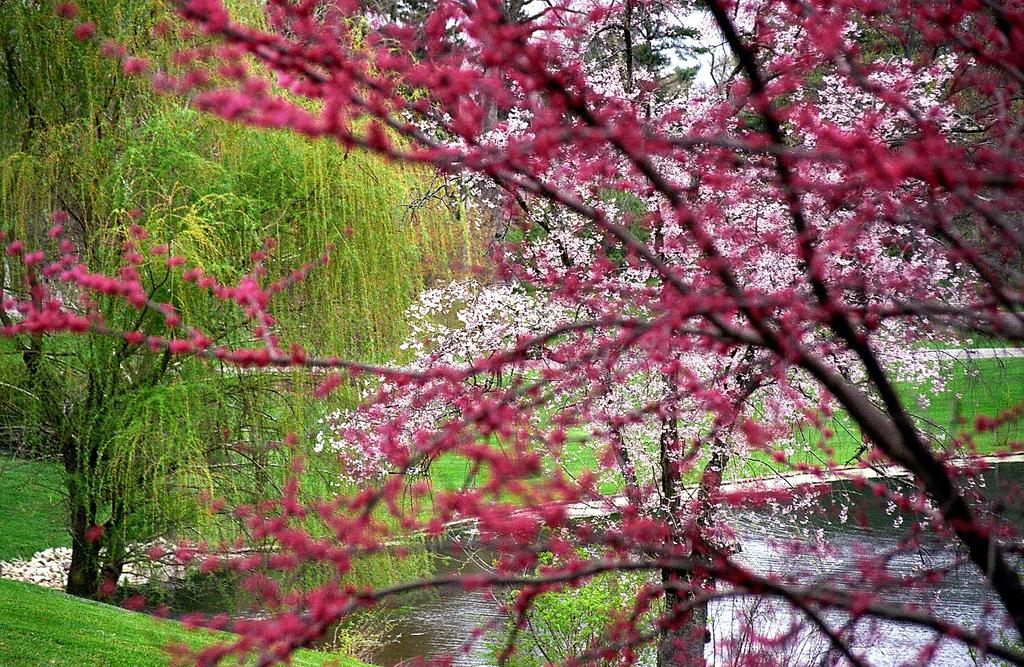What is visible in the image that represents a natural body of water? There is water visible in the image. What type of vegetation can be seen in the image? There are trees and flowers in the image. What type of ground cover is present in the image? There is grass on the ground in the image. Can you see a gun being used by someone in the image? There is no gun or person visible in the image. Is there a grandmother tending to the flowers in the image? There is no grandmother or person visible in the image. 